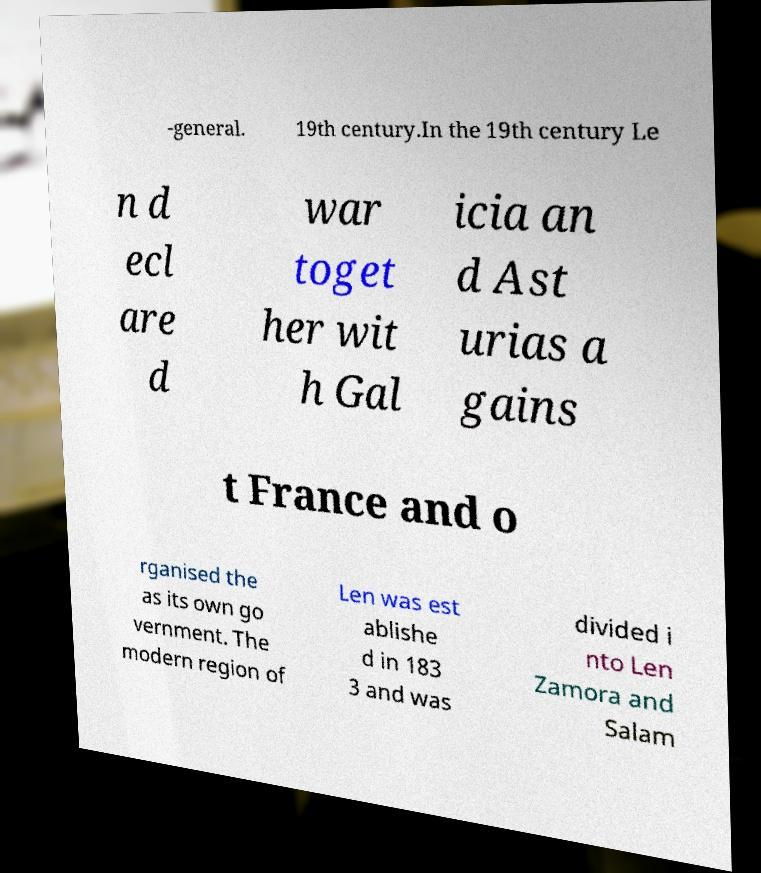Please identify and transcribe the text found in this image. -general. 19th century.In the 19th century Le n d ecl are d war toget her wit h Gal icia an d Ast urias a gains t France and o rganised the as its own go vernment. The modern region of Len was est ablishe d in 183 3 and was divided i nto Len Zamora and Salam 